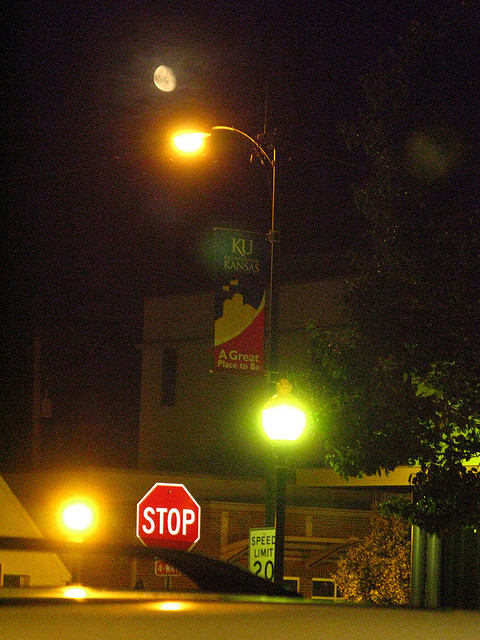Please transcribe the text in this image. STOP SPEED KANSAS KU 20 place Great A 